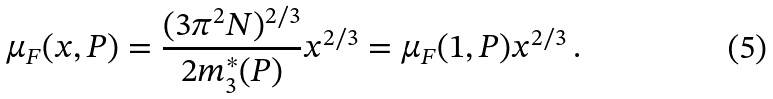<formula> <loc_0><loc_0><loc_500><loc_500>\mu _ { F } ( x , P ) = \frac { ( 3 \pi ^ { 2 } N ) ^ { 2 / 3 } } { 2 m _ { 3 } ^ { * } ( P ) } x ^ { 2 / 3 } = \mu _ { F } ( 1 , P ) x ^ { 2 / 3 } \, .</formula> 